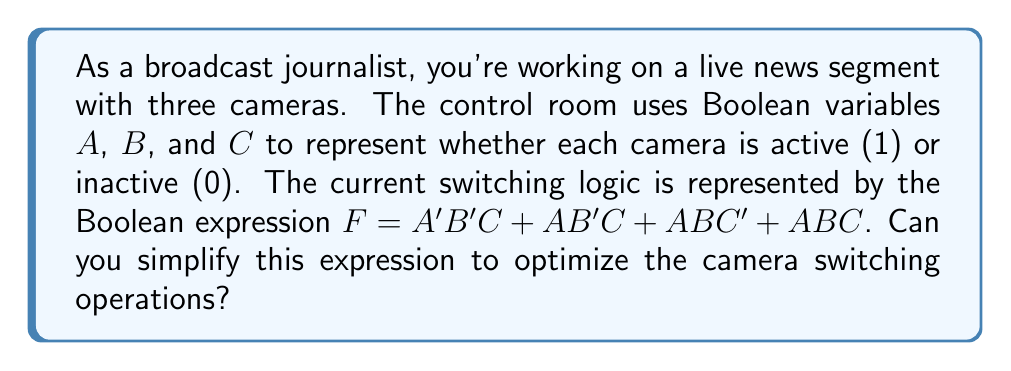Give your solution to this math problem. Let's simplify the Boolean expression step by step:

1) Start with the given expression:
   $F = A'B'C + AB'C + ABC' + ABC$

2) Group terms with $B'C$:
   $F = (A' + A)B'C + ABC' + ABC$

3) Simplify $(A' + A)$ to 1:
   $F = B'C + ABC' + ABC$

4) Factor out $AC$ from the last two terms:
   $F = B'C + AC(B' + B)$

5) Simplify $(B' + B)$ to 1:
   $F = B'C + AC$

6) Apply the distributive property:
   $F = (B' + A)C$

Therefore, the simplified Boolean expression for the camera switching logic is $(B' + A)C$.

This simplification reduces the complexity of the switching logic, potentially leading to faster and more efficient camera switching operations in the broadcast control room.
Answer: $(B' + A)C$ 